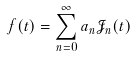<formula> <loc_0><loc_0><loc_500><loc_500>f ( t ) = \sum _ { n = 0 } ^ { \infty } a _ { n } \mathcal { J } _ { n } ( t )</formula> 